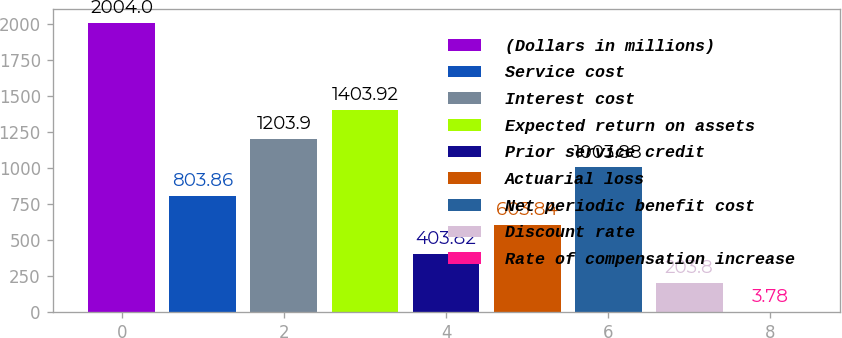Convert chart. <chart><loc_0><loc_0><loc_500><loc_500><bar_chart><fcel>(Dollars in millions)<fcel>Service cost<fcel>Interest cost<fcel>Expected return on assets<fcel>Prior service credit<fcel>Actuarial loss<fcel>Net periodic benefit cost<fcel>Discount rate<fcel>Rate of compensation increase<nl><fcel>2004<fcel>803.86<fcel>1203.9<fcel>1403.92<fcel>403.82<fcel>603.84<fcel>1003.88<fcel>203.8<fcel>3.78<nl></chart> 